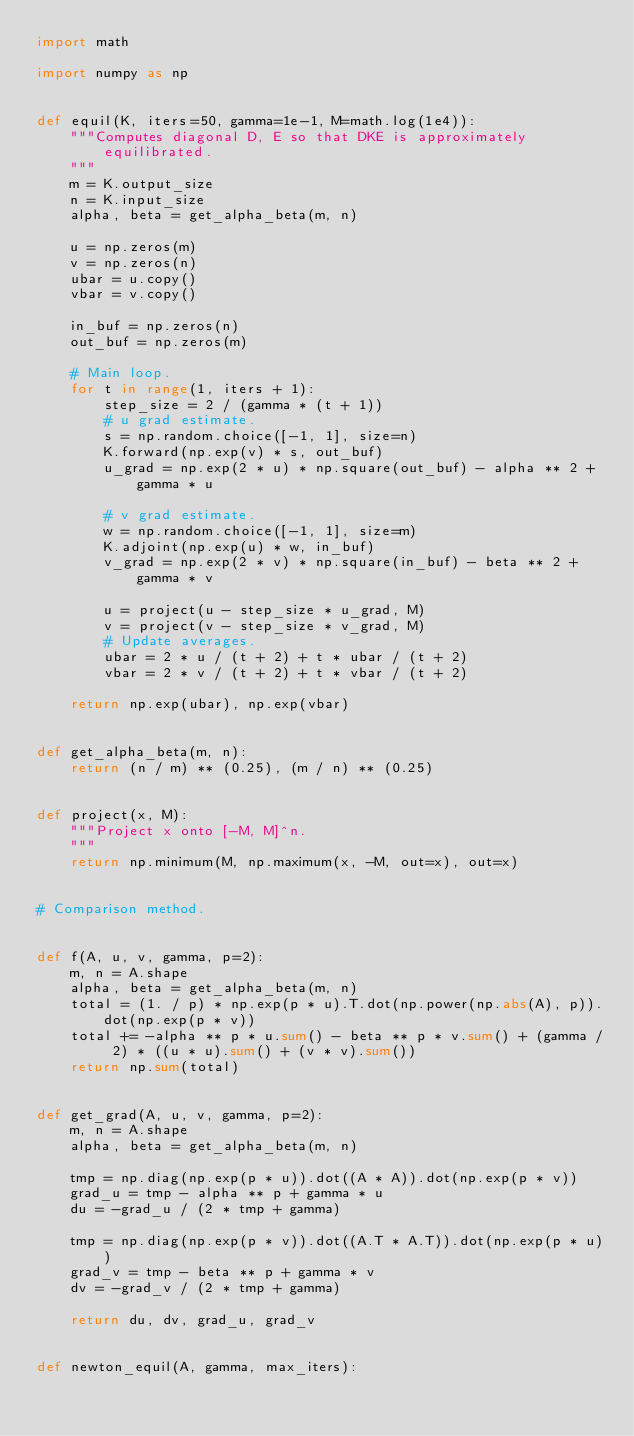Convert code to text. <code><loc_0><loc_0><loc_500><loc_500><_Python_>import math

import numpy as np


def equil(K, iters=50, gamma=1e-1, M=math.log(1e4)):
    """Computes diagonal D, E so that DKE is approximately equilibrated.
    """
    m = K.output_size
    n = K.input_size
    alpha, beta = get_alpha_beta(m, n)

    u = np.zeros(m)
    v = np.zeros(n)
    ubar = u.copy()
    vbar = v.copy()

    in_buf = np.zeros(n)
    out_buf = np.zeros(m)

    # Main loop.
    for t in range(1, iters + 1):
        step_size = 2 / (gamma * (t + 1))
        # u grad estimate.
        s = np.random.choice([-1, 1], size=n)
        K.forward(np.exp(v) * s, out_buf)
        u_grad = np.exp(2 * u) * np.square(out_buf) - alpha ** 2 + gamma * u

        # v grad estimate.
        w = np.random.choice([-1, 1], size=m)
        K.adjoint(np.exp(u) * w, in_buf)
        v_grad = np.exp(2 * v) * np.square(in_buf) - beta ** 2 + gamma * v

        u = project(u - step_size * u_grad, M)
        v = project(v - step_size * v_grad, M)
        # Update averages.
        ubar = 2 * u / (t + 2) + t * ubar / (t + 2)
        vbar = 2 * v / (t + 2) + t * vbar / (t + 2)

    return np.exp(ubar), np.exp(vbar)


def get_alpha_beta(m, n):
    return (n / m) ** (0.25), (m / n) ** (0.25)


def project(x, M):
    """Project x onto [-M, M]^n.
    """
    return np.minimum(M, np.maximum(x, -M, out=x), out=x)


# Comparison method.


def f(A, u, v, gamma, p=2):
    m, n = A.shape
    alpha, beta = get_alpha_beta(m, n)
    total = (1. / p) * np.exp(p * u).T.dot(np.power(np.abs(A), p)).dot(np.exp(p * v))
    total += -alpha ** p * u.sum() - beta ** p * v.sum() + (gamma / 2) * ((u * u).sum() + (v * v).sum())
    return np.sum(total)


def get_grad(A, u, v, gamma, p=2):
    m, n = A.shape
    alpha, beta = get_alpha_beta(m, n)

    tmp = np.diag(np.exp(p * u)).dot((A * A)).dot(np.exp(p * v))
    grad_u = tmp - alpha ** p + gamma * u
    du = -grad_u / (2 * tmp + gamma)

    tmp = np.diag(np.exp(p * v)).dot((A.T * A.T)).dot(np.exp(p * u))
    grad_v = tmp - beta ** p + gamma * v
    dv = -grad_v / (2 * tmp + gamma)

    return du, dv, grad_u, grad_v


def newton_equil(A, gamma, max_iters):</code> 